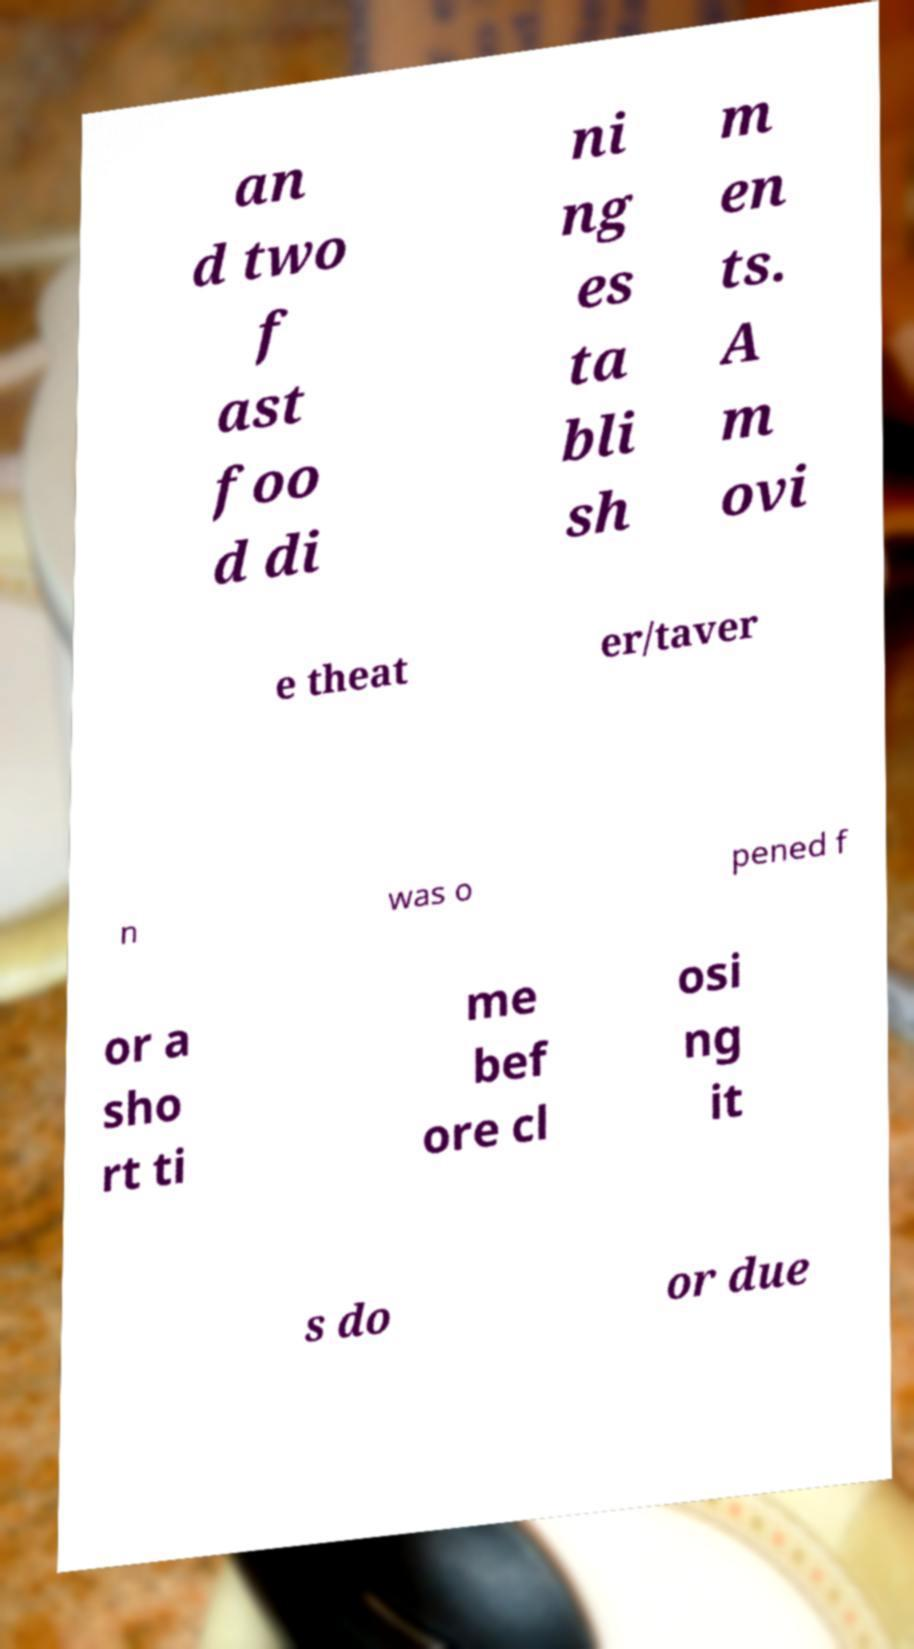For documentation purposes, I need the text within this image transcribed. Could you provide that? an d two f ast foo d di ni ng es ta bli sh m en ts. A m ovi e theat er/taver n was o pened f or a sho rt ti me bef ore cl osi ng it s do or due 